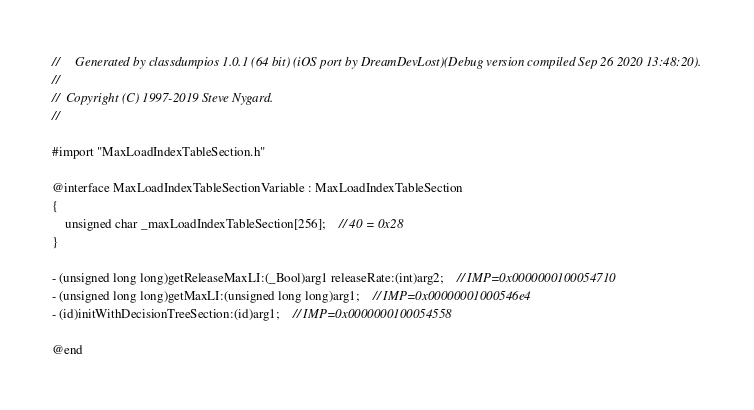<code> <loc_0><loc_0><loc_500><loc_500><_C_>//     Generated by classdumpios 1.0.1 (64 bit) (iOS port by DreamDevLost)(Debug version compiled Sep 26 2020 13:48:20).
//
//  Copyright (C) 1997-2019 Steve Nygard.
//

#import "MaxLoadIndexTableSection.h"

@interface MaxLoadIndexTableSectionVariable : MaxLoadIndexTableSection
{
    unsigned char _maxLoadIndexTableSection[256];	// 40 = 0x28
}

- (unsigned long long)getReleaseMaxLI:(_Bool)arg1 releaseRate:(int)arg2;	// IMP=0x0000000100054710
- (unsigned long long)getMaxLI:(unsigned long long)arg1;	// IMP=0x00000001000546e4
- (id)initWithDecisionTreeSection:(id)arg1;	// IMP=0x0000000100054558

@end

</code> 